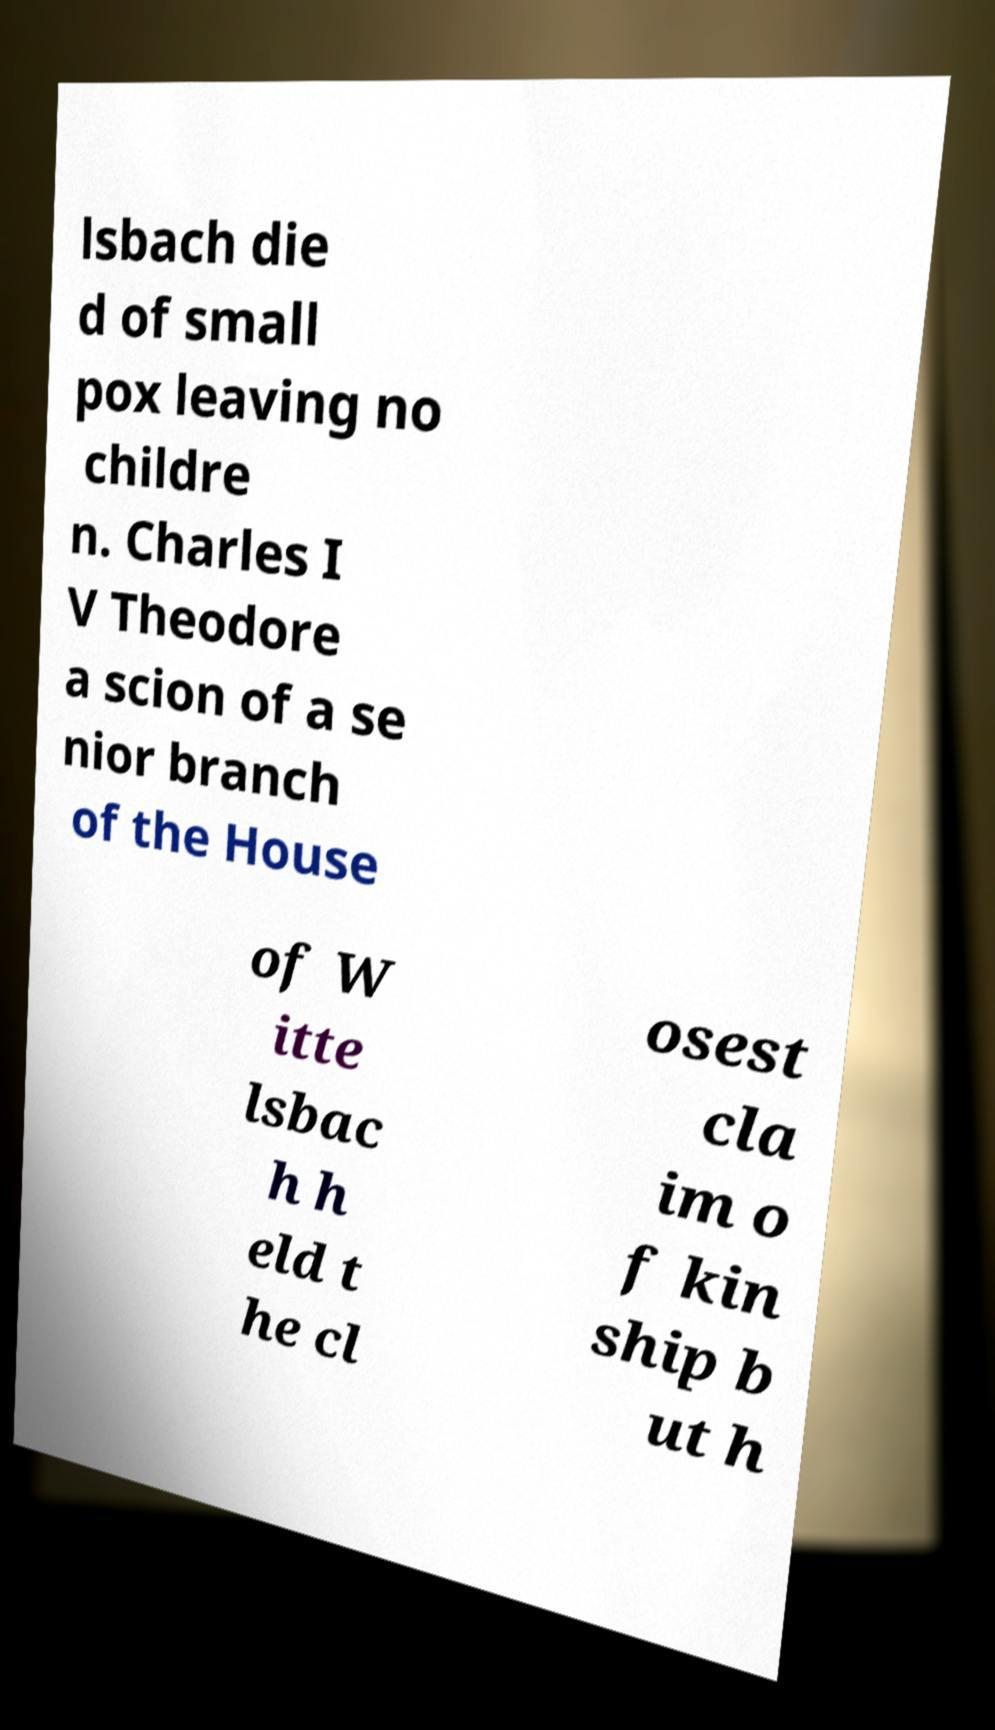What messages or text are displayed in this image? I need them in a readable, typed format. lsbach die d of small pox leaving no childre n. Charles I V Theodore a scion of a se nior branch of the House of W itte lsbac h h eld t he cl osest cla im o f kin ship b ut h 